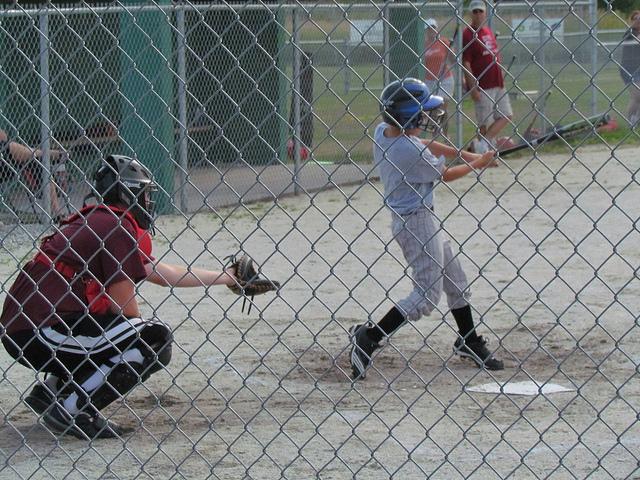What color is the boy's bat?
Short answer required. Black. Are the players in a fenced area?
Short answer required. Yes. What color is the boy's jersey?
Answer briefly. Gray. Where is home plate?
Give a very brief answer. On ground. Did the player swing at the ball?
Keep it brief. Yes. Are both men wearing shirts?
Answer briefly. Yes. 